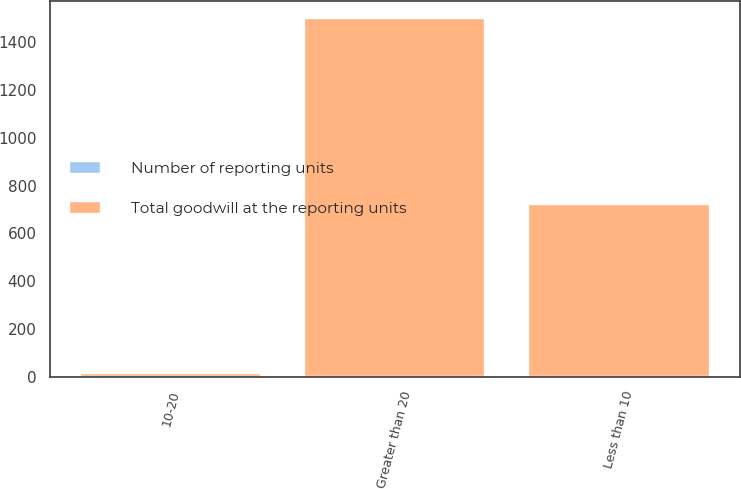<chart> <loc_0><loc_0><loc_500><loc_500><stacked_bar_chart><ecel><fcel>Less than 10<fcel>10-20<fcel>Greater than 20<nl><fcel>Number of reporting units<fcel>3<fcel>1<fcel>4<nl><fcel>Total goodwill at the reporting units<fcel>715<fcel>12.2<fcel>1493.7<nl></chart> 